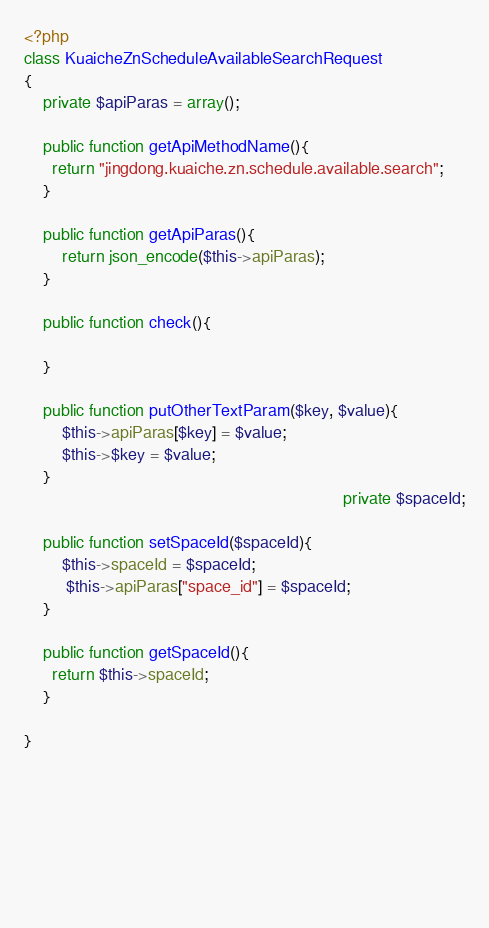Convert code to text. <code><loc_0><loc_0><loc_500><loc_500><_PHP_><?php
class KuaicheZnScheduleAvailableSearchRequest
{
	private $apiParas = array();
	
	public function getApiMethodName(){
	  return "jingdong.kuaiche.zn.schedule.available.search";
	}
	
	public function getApiParas(){
		return json_encode($this->apiParas);
	}
	
	public function check(){
		
	}
	
	public function putOtherTextParam($key, $value){
		$this->apiParas[$key] = $value;
		$this->$key = $value;
	}
                                    	                   			private $spaceId;
    	                                                            
	public function setSpaceId($spaceId){
		$this->spaceId = $spaceId;
         $this->apiParas["space_id"] = $spaceId;
	}

	public function getSpaceId(){
	  return $this->spaceId;
	}

}





        
 

</code> 